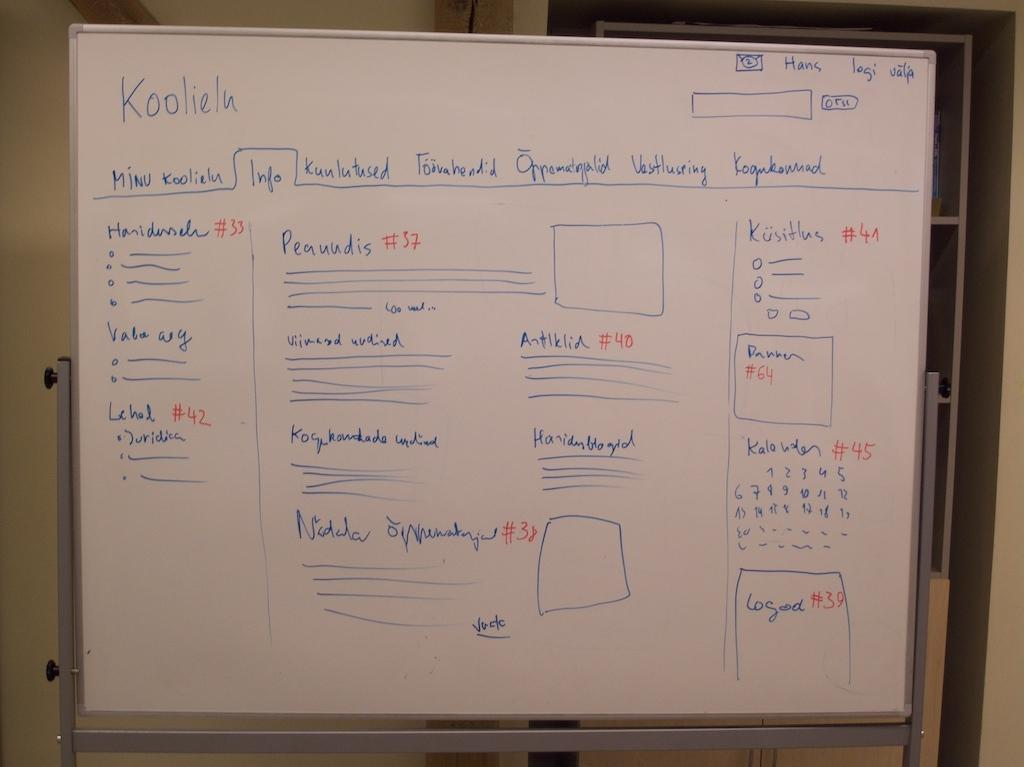<image>
Relay a brief, clear account of the picture shown. A whiteboard covered in words and diagrams written in blue marker, the word Koolieln is written in the top left. 